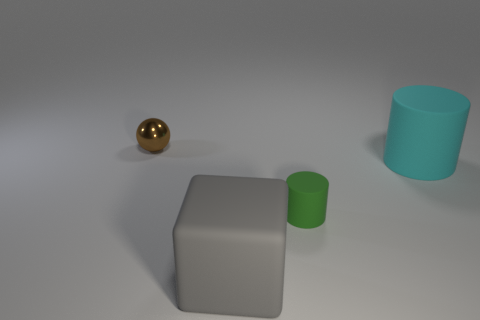Add 4 big gray objects. How many objects exist? 8 Subtract all balls. How many objects are left? 3 Subtract all large brown matte objects. Subtract all matte blocks. How many objects are left? 3 Add 1 green rubber cylinders. How many green rubber cylinders are left? 2 Add 1 small yellow things. How many small yellow things exist? 1 Subtract 1 cyan cylinders. How many objects are left? 3 